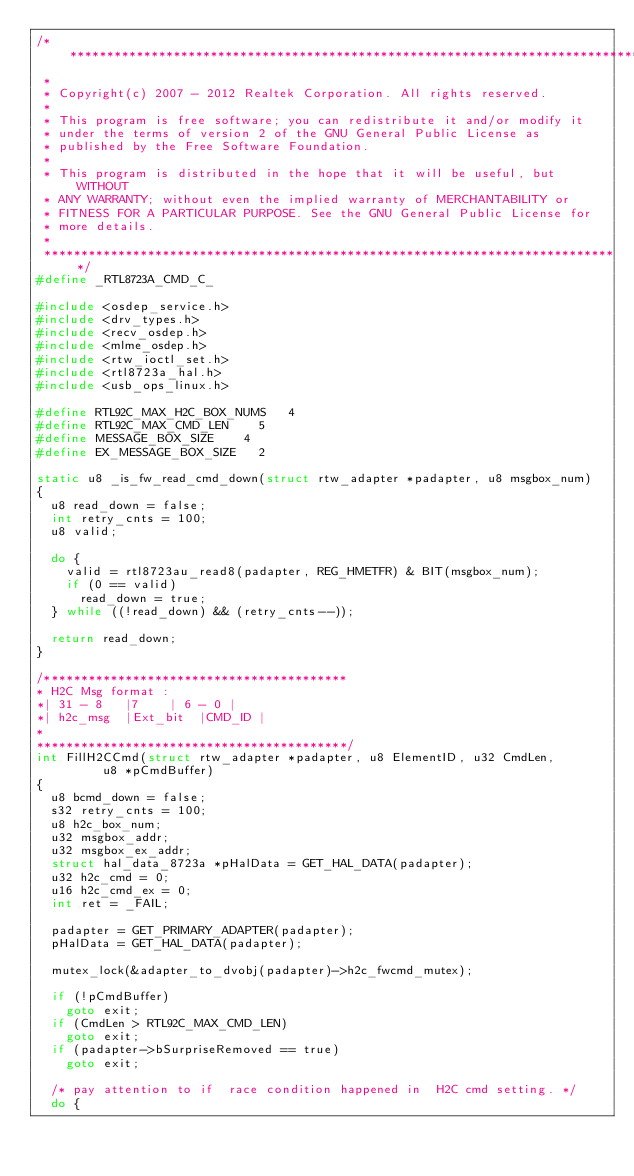Convert code to text. <code><loc_0><loc_0><loc_500><loc_500><_C_>/******************************************************************************
 *
 * Copyright(c) 2007 - 2012 Realtek Corporation. All rights reserved.
 *
 * This program is free software; you can redistribute it and/or modify it
 * under the terms of version 2 of the GNU General Public License as
 * published by the Free Software Foundation.
 *
 * This program is distributed in the hope that it will be useful, but WITHOUT
 * ANY WARRANTY; without even the implied warranty of MERCHANTABILITY or
 * FITNESS FOR A PARTICULAR PURPOSE. See the GNU General Public License for
 * more details.
 *
 ******************************************************************************/
#define _RTL8723A_CMD_C_

#include <osdep_service.h>
#include <drv_types.h>
#include <recv_osdep.h>
#include <mlme_osdep.h>
#include <rtw_ioctl_set.h>
#include <rtl8723a_hal.h>
#include <usb_ops_linux.h>

#define RTL92C_MAX_H2C_BOX_NUMS		4
#define RTL92C_MAX_CMD_LEN		5
#define MESSAGE_BOX_SIZE		4
#define EX_MESSAGE_BOX_SIZE		2

static u8 _is_fw_read_cmd_down(struct rtw_adapter *padapter, u8 msgbox_num)
{
	u8 read_down = false;
	int	retry_cnts = 100;
	u8 valid;

	do {
		valid = rtl8723au_read8(padapter, REG_HMETFR) & BIT(msgbox_num);
		if (0 == valid)
			read_down = true;
	} while ((!read_down) && (retry_cnts--));

	return read_down;
}

/*****************************************
* H2C Msg format :
*| 31 - 8		|7		| 6 - 0	|
*| h2c_msg	|Ext_bit	|CMD_ID	|
*
******************************************/
int FillH2CCmd(struct rtw_adapter *padapter, u8 ElementID, u32 CmdLen,
	       u8 *pCmdBuffer)
{
	u8 bcmd_down = false;
	s32 retry_cnts = 100;
	u8 h2c_box_num;
	u32 msgbox_addr;
	u32 msgbox_ex_addr;
	struct hal_data_8723a *pHalData = GET_HAL_DATA(padapter);
	u32 h2c_cmd = 0;
	u16 h2c_cmd_ex = 0;
	int ret = _FAIL;

	padapter = GET_PRIMARY_ADAPTER(padapter);
	pHalData = GET_HAL_DATA(padapter);

	mutex_lock(&adapter_to_dvobj(padapter)->h2c_fwcmd_mutex);

	if (!pCmdBuffer)
		goto exit;
	if (CmdLen > RTL92C_MAX_CMD_LEN)
		goto exit;
	if (padapter->bSurpriseRemoved == true)
		goto exit;

	/* pay attention to if  race condition happened in  H2C cmd setting. */
	do {</code> 